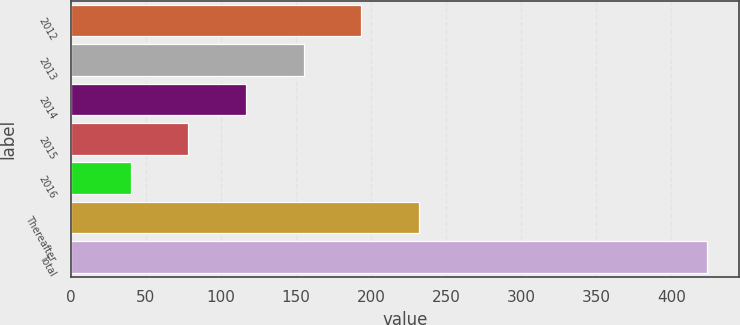Convert chart. <chart><loc_0><loc_0><loc_500><loc_500><bar_chart><fcel>2012<fcel>2013<fcel>2014<fcel>2015<fcel>2016<fcel>Thereafter<fcel>Total<nl><fcel>193.6<fcel>155.2<fcel>116.8<fcel>78.4<fcel>40<fcel>232<fcel>424<nl></chart> 